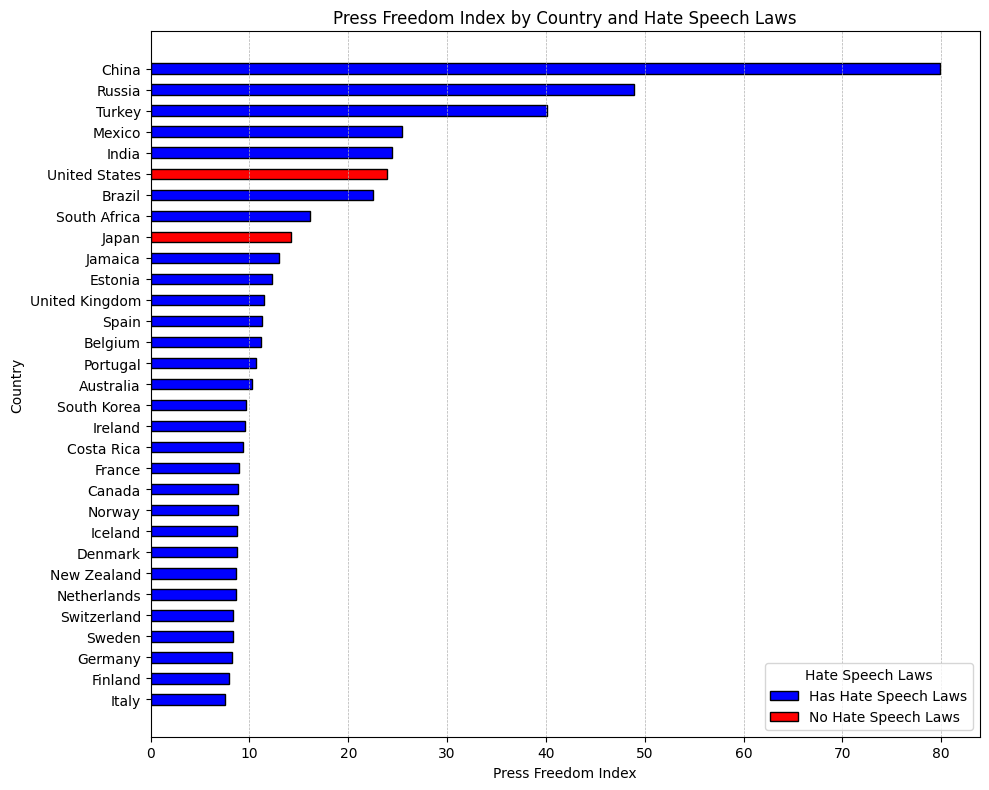Which country has the highest Press Freedom Index? To find the country with the highest Press Freedom Index, look for the longest bar in the horizontal bar chart. The bar for China is the longest, indicating it has the highest Press Freedom Index of 79.92.
Answer: China Among countries with hate speech laws, which one has the lowest Press Freedom Index? To determine this, look among the blue bars (representing countries with hate speech laws) for the shortest one. Italy has the shortest blue bar, representing a Press Freedom Index of 7.56.
Answer: Italy Compare the Press Freedom Index of the United States and South Korea. Which is higher? Observe the lengths of the bars for the United States (red) and South Korea (blue). The bar for South Korea is shorter than the one for the United States. Therefore, the United States has a higher Press Freedom Index of 23.93 compared to South Korea's 9.67.
Answer: United States What is the average Press Freedom Index of the top 5 countries with hate speech laws? Identify the top 5 countries with the shortest blue bars: Norway (8.82), Finland (7.94), Sweden (8.31), Netherlands (8.62), and Switzerland (8.38). Calculate the average: (8.82 + 7.94 + 8.31 + 8.62 + 8.38) / 5 = 8.41.
Answer: 8.41 Which color represents countries without hate speech laws, and how many such countries are there? From the legend, countries without hate speech laws are represented by red bars. Count the red bars on the chart: there are two such countries (United States and Japan).
Answer: Red, 2 What is the difference in Press Freedom Index between the highest and lowest-ranked countries with hate speech laws? Identify the highest (China, 79.92) and lowest (Italy, 7.56) Press Freedom Index among countries with hate speech laws. Calculate the difference: 79.92 - 7.56 = 72.36.
Answer: 72.36 How many countries have a Press Freedom Index greater than 20, and do they have hate speech laws? Look at the bars greater than 20: United States (23.93, no), India (24.41, yes), Brazil (22.54, yes), Mexico (25.44, yes), Turkey (40.14, yes), China (79.92, yes), Russia (48.94, yes). Out of 7 countries, 6 have hate speech laws.
Answer: 7, 6 have hate speech laws Which European country has the highest Press Freedom Index? Identify European countries and find the one with the longest bar. Norway has the highest Press Freedom Index among European countries with an index of 8.82.
Answer: Norway What is the median Press Freedom Index for all countries in the dataset? Sort the countries by Press Freedom Index and pick the middle value. Sorting gives: 7.56, 7.94, 8.21, 8.31, 8.38, 8.62, 8.64, 8.72, 8.76, 8.82, 8.87, 8.93, 9.31, 9.54, 9.67, 10.21, 10.64, 11.13, 11.29, 11.42, 12.24, 12.95, 14.22, 16.13, 22.54, 23.93, 24.41, 25.44, 40.14, 48.94, 79.92. The median is the 16th value, which is 10.64.
Answer: 10.64 Compare the Press Freedom Index for Norway and Sweden. Which country has a higher index, and what is the difference? Observe the bar lengths for Norway (8.82) and Sweden (8.31). Norway has a higher index. The difference is: 8.82 - 8.31 = 0.51.
Answer: Norway, 0.51 